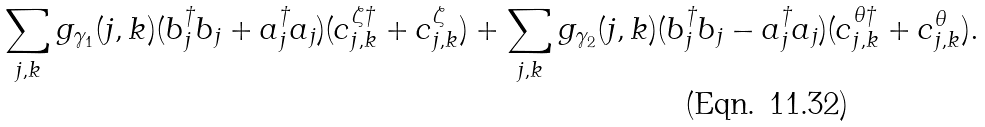<formula> <loc_0><loc_0><loc_500><loc_500>\sum _ { j , k } g _ { \gamma _ { 1 } } ( j , k ) ( b ^ { \dagger } _ { j } b _ { j } + a ^ { \dagger } _ { j } a _ { j } ) ( c _ { j , k } ^ { \zeta \dagger } + c _ { j , k } ^ { \zeta } ) + \sum _ { j , k } g _ { \gamma _ { 2 } } ( j , k ) ( b ^ { \dagger } _ { j } b _ { j } - a ^ { \dagger } _ { j } a _ { j } ) ( c _ { j , k } ^ { \theta \dagger } + c _ { j , k } ^ { \theta } ) .</formula> 